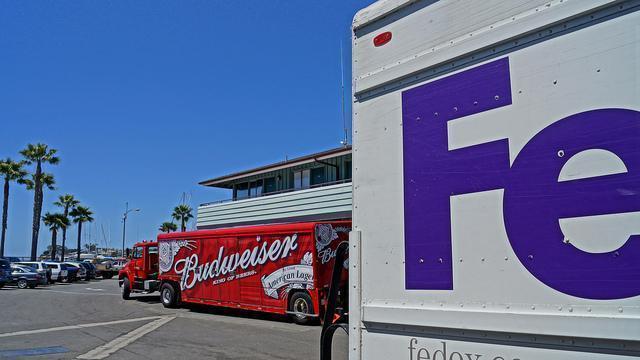What service does the vehicle with the purple letters provide?
Choose the right answer and clarify with the format: 'Answer: answer
Rationale: rationale.'
Options: Deliveries, groceries, alcohol, security. Answer: deliveries.
Rationale: Fedex delivers packages. 